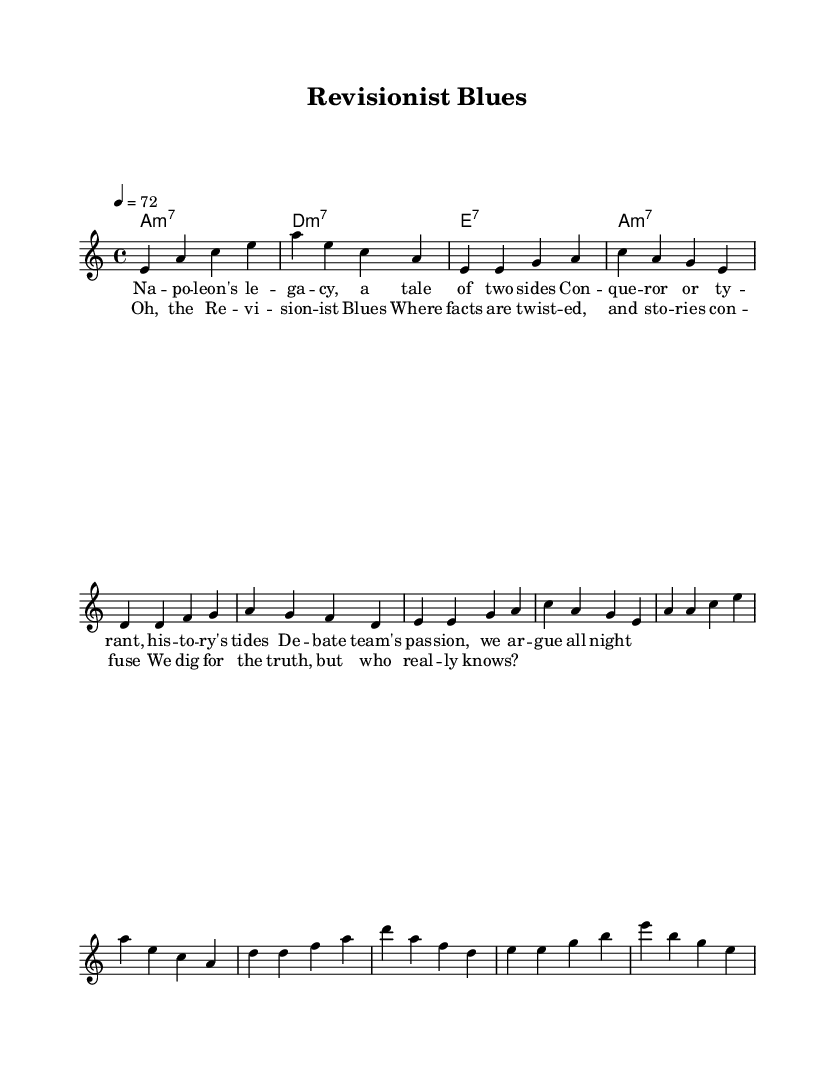What is the key signature of this music? The key signature of the piece is indicated at the beginning of the score with the note "a". This means it follows the A minor scale, which has no sharps or flats.
Answer: A minor What is the time signature of this music? The time signature is shown at the start of the piece as "4/4", meaning that there are four beats in a measure and the quarter note gets one beat.
Answer: 4/4 What is the tempo marking for this piece? The tempo marking is denoted by “4 = 72”, indicating that there are 72 beats per minute, and each beat is a quarter note.
Answer: 72 What form of music is this piece classified as? Since the title includes "Blues" and it contains elements typical of that genre, we deduce it is a Blues song, which typically focuses on themes of struggle and legacy.
Answer: Blues How many measures are in the verse section? By counting the bars in the verse from the score, there are three complete phrases leading to a total of 6 measures.
Answer: 6 measures Identify the main theme of the lyrics. The lyrics present a contention between different interpretations of Napoleon's legacy, illustrating the debates surrounding historical figures and how they're perceived differently.
Answer: Napoleon's legacy What chords are used in the chorus? The chords in this piece are displayed using chord notation underneath the melody; for the chorus, they are D minor 7, A minor 7, and E7, confirming the typical Blues chord progression.
Answer: D minor 7, A minor 7, E7 